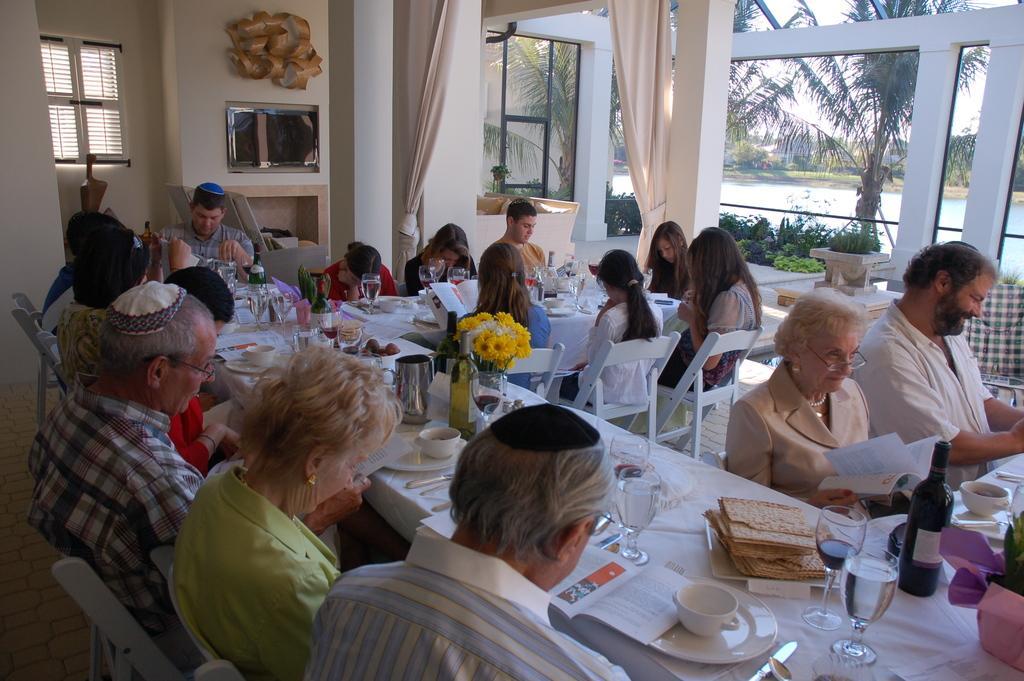How would you summarize this image in a sentence or two? people are sitting on the chairs across the table. on the table there are books, glasses, cup, saucer, knife, food, flowers, bottle. at the back there are wall, curtains. outside the building there are trees and water. 